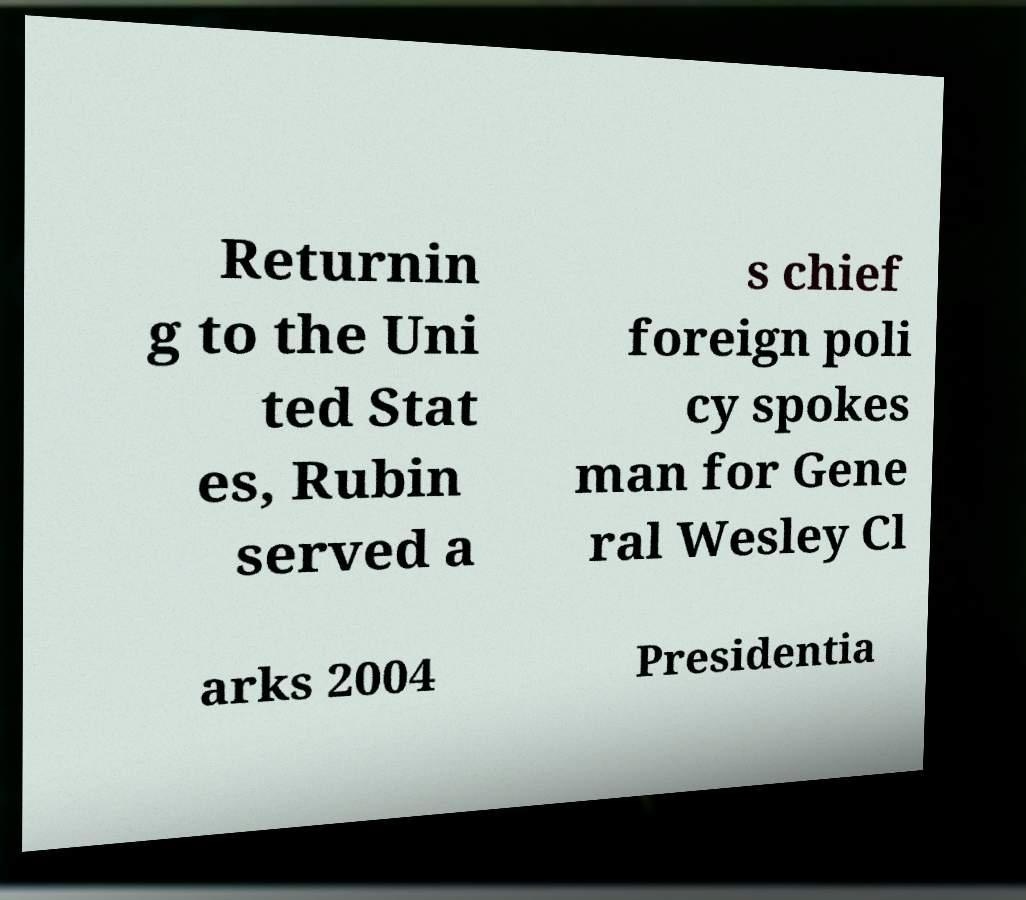Can you read and provide the text displayed in the image?This photo seems to have some interesting text. Can you extract and type it out for me? Returnin g to the Uni ted Stat es, Rubin served a s chief foreign poli cy spokes man for Gene ral Wesley Cl arks 2004 Presidentia 